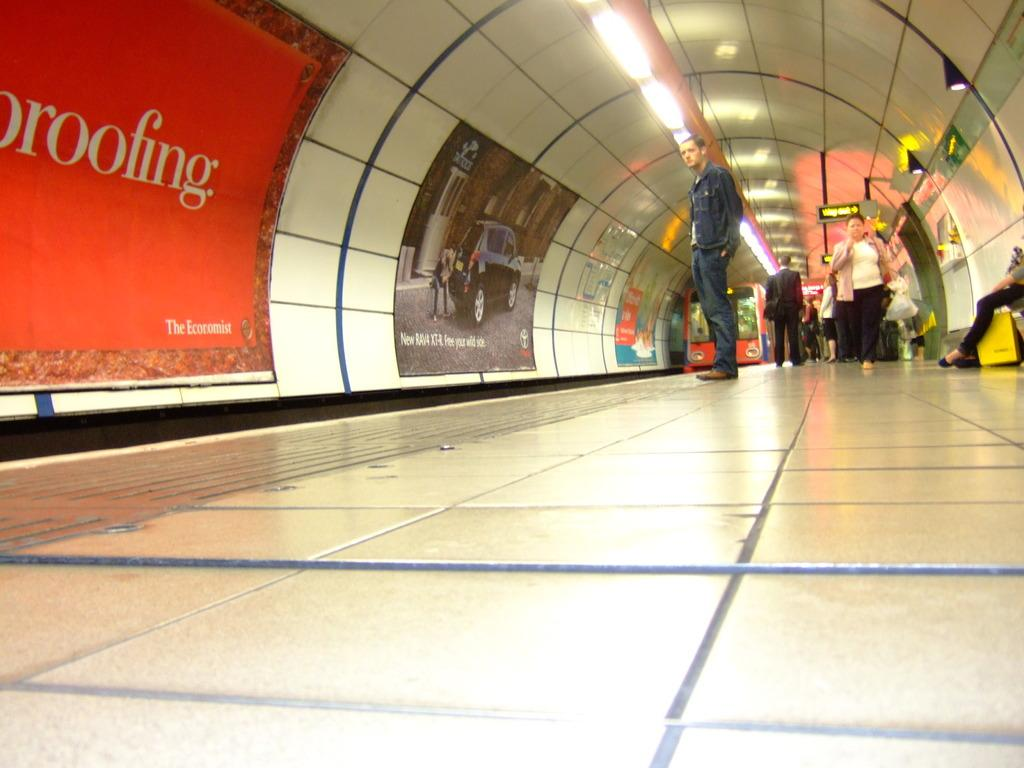What are the people in the image doing? The people in the image are on the floor. What else can be seen in the image besides the people? There is a train visible in the image, as well as posters attached to the wall. What type of lighting is present in the image? The image includes ceiling lights. What verse is being recited by the people on the floor in the image? There is no verse being recited in the image; the people are simply on the floor. How comfortable are the people on the floor in the image? The image does not provide information about the comfort level of the people on the floor. 